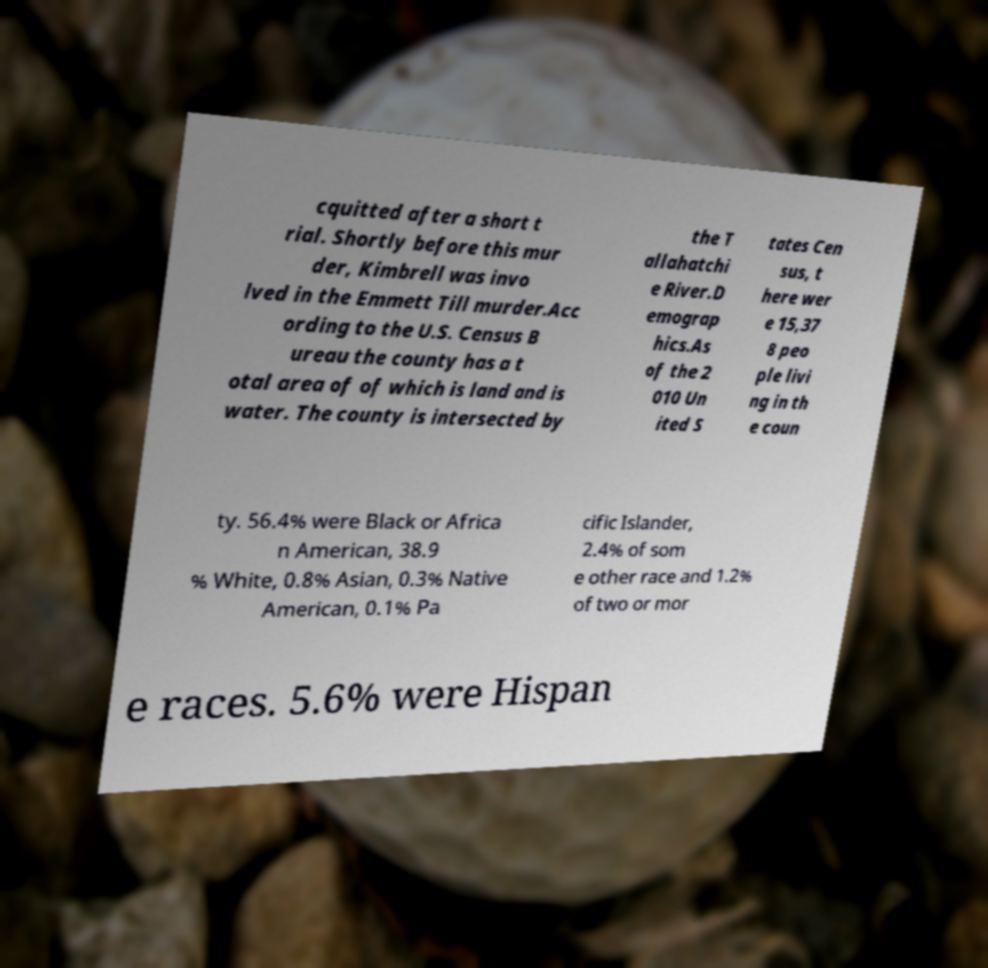Please identify and transcribe the text found in this image. cquitted after a short t rial. Shortly before this mur der, Kimbrell was invo lved in the Emmett Till murder.Acc ording to the U.S. Census B ureau the county has a t otal area of of which is land and is water. The county is intersected by the T allahatchi e River.D emograp hics.As of the 2 010 Un ited S tates Cen sus, t here wer e 15,37 8 peo ple livi ng in th e coun ty. 56.4% were Black or Africa n American, 38.9 % White, 0.8% Asian, 0.3% Native American, 0.1% Pa cific Islander, 2.4% of som e other race and 1.2% of two or mor e races. 5.6% were Hispan 